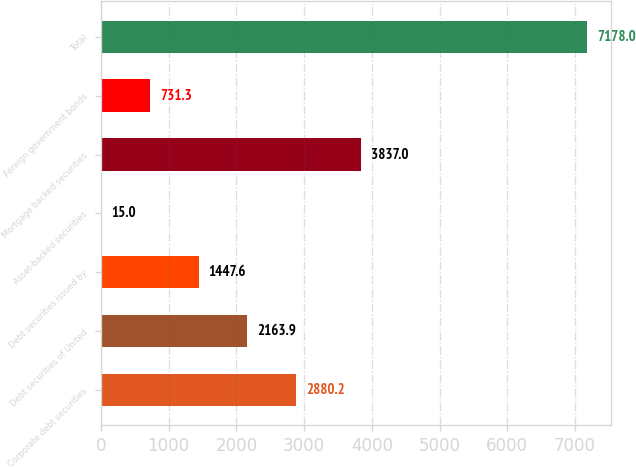Convert chart to OTSL. <chart><loc_0><loc_0><loc_500><loc_500><bar_chart><fcel>Corporate debt securities<fcel>Debt securities of United<fcel>Debt securities issued by<fcel>Asset-backed securities<fcel>Mortgage backed securities<fcel>Foreign government bonds<fcel>Total<nl><fcel>2880.2<fcel>2163.9<fcel>1447.6<fcel>15<fcel>3837<fcel>731.3<fcel>7178<nl></chart> 